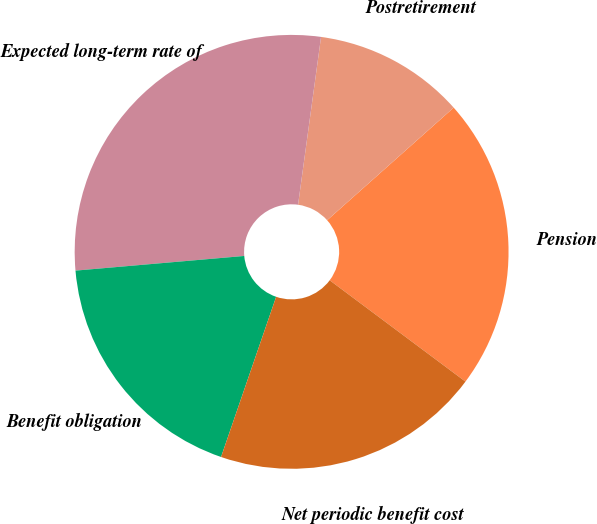Convert chart to OTSL. <chart><loc_0><loc_0><loc_500><loc_500><pie_chart><fcel>Pension<fcel>Postretirement<fcel>Expected long-term rate of<fcel>Benefit obligation<fcel>Net periodic benefit cost<nl><fcel>21.78%<fcel>11.26%<fcel>28.55%<fcel>18.35%<fcel>20.07%<nl></chart> 